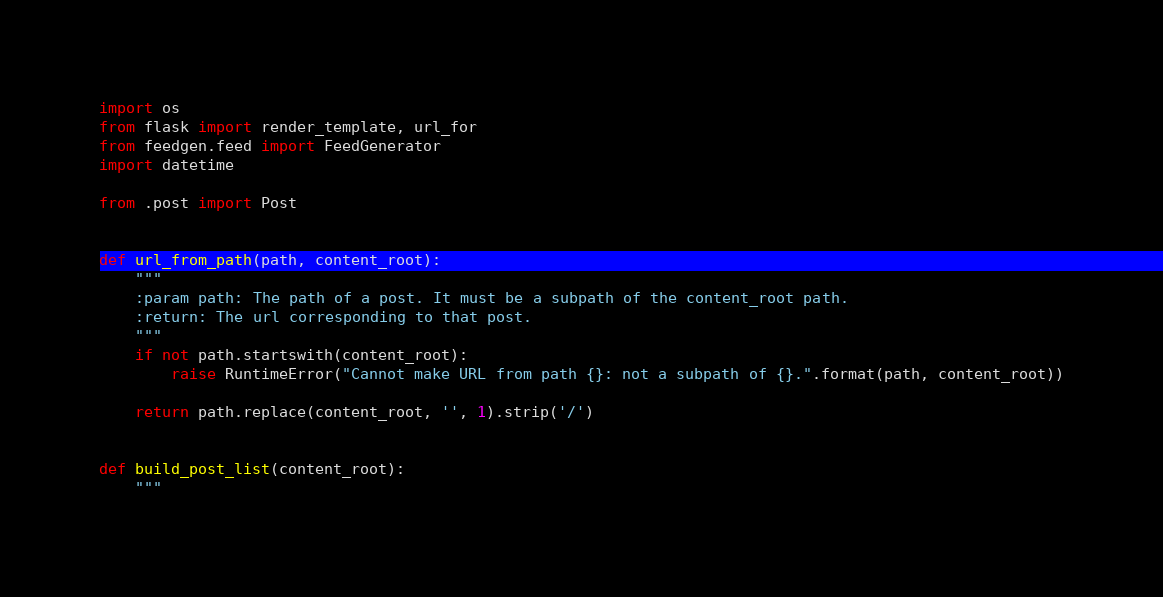Convert code to text. <code><loc_0><loc_0><loc_500><loc_500><_Python_>import os
from flask import render_template, url_for
from feedgen.feed import FeedGenerator
import datetime

from .post import Post


def url_from_path(path, content_root):
    """
    :param path: The path of a post. It must be a subpath of the content_root path.
    :return: The url corresponding to that post.
    """
    if not path.startswith(content_root):
        raise RuntimeError("Cannot make URL from path {}: not a subpath of {}.".format(path, content_root))

    return path.replace(content_root, '', 1).strip('/')


def build_post_list(content_root):
    """</code> 